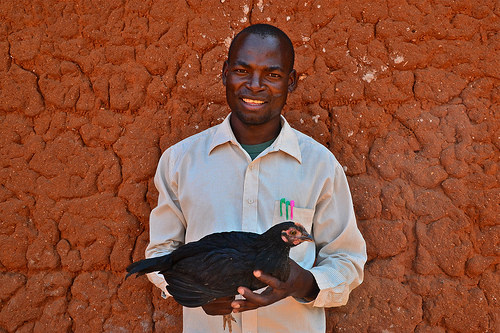<image>
Is there a wall behind the hen? Yes. From this viewpoint, the wall is positioned behind the hen, with the hen partially or fully occluding the wall. 